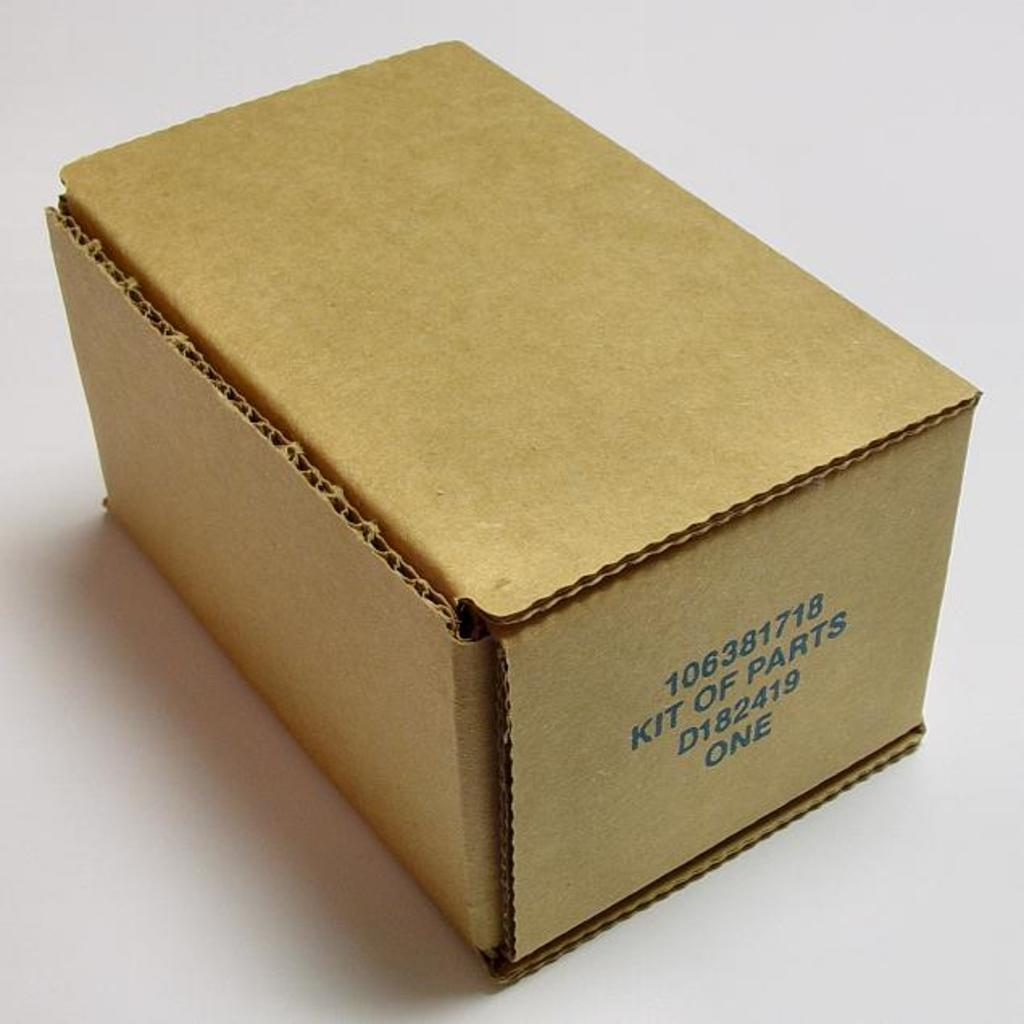<image>
Summarize the visual content of the image. A brown cardboard box labeled "kit of parts" 